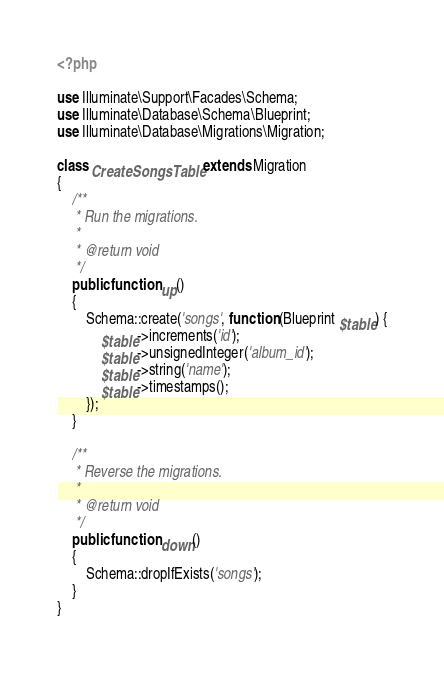<code> <loc_0><loc_0><loc_500><loc_500><_PHP_><?php

use Illuminate\Support\Facades\Schema;
use Illuminate\Database\Schema\Blueprint;
use Illuminate\Database\Migrations\Migration;

class CreateSongsTable extends Migration
{
    /**
     * Run the migrations.
     *
     * @return void
     */
    public function up()
    {
        Schema::create('songs', function (Blueprint $table) {
            $table->increments('id');
            $table->unsignedInteger('album_id');
            $table->string('name');
            $table->timestamps();
        });
    }

    /**
     * Reverse the migrations.
     *
     * @return void
     */
    public function down()
    {
        Schema::dropIfExists('songs');
    }
}
</code> 